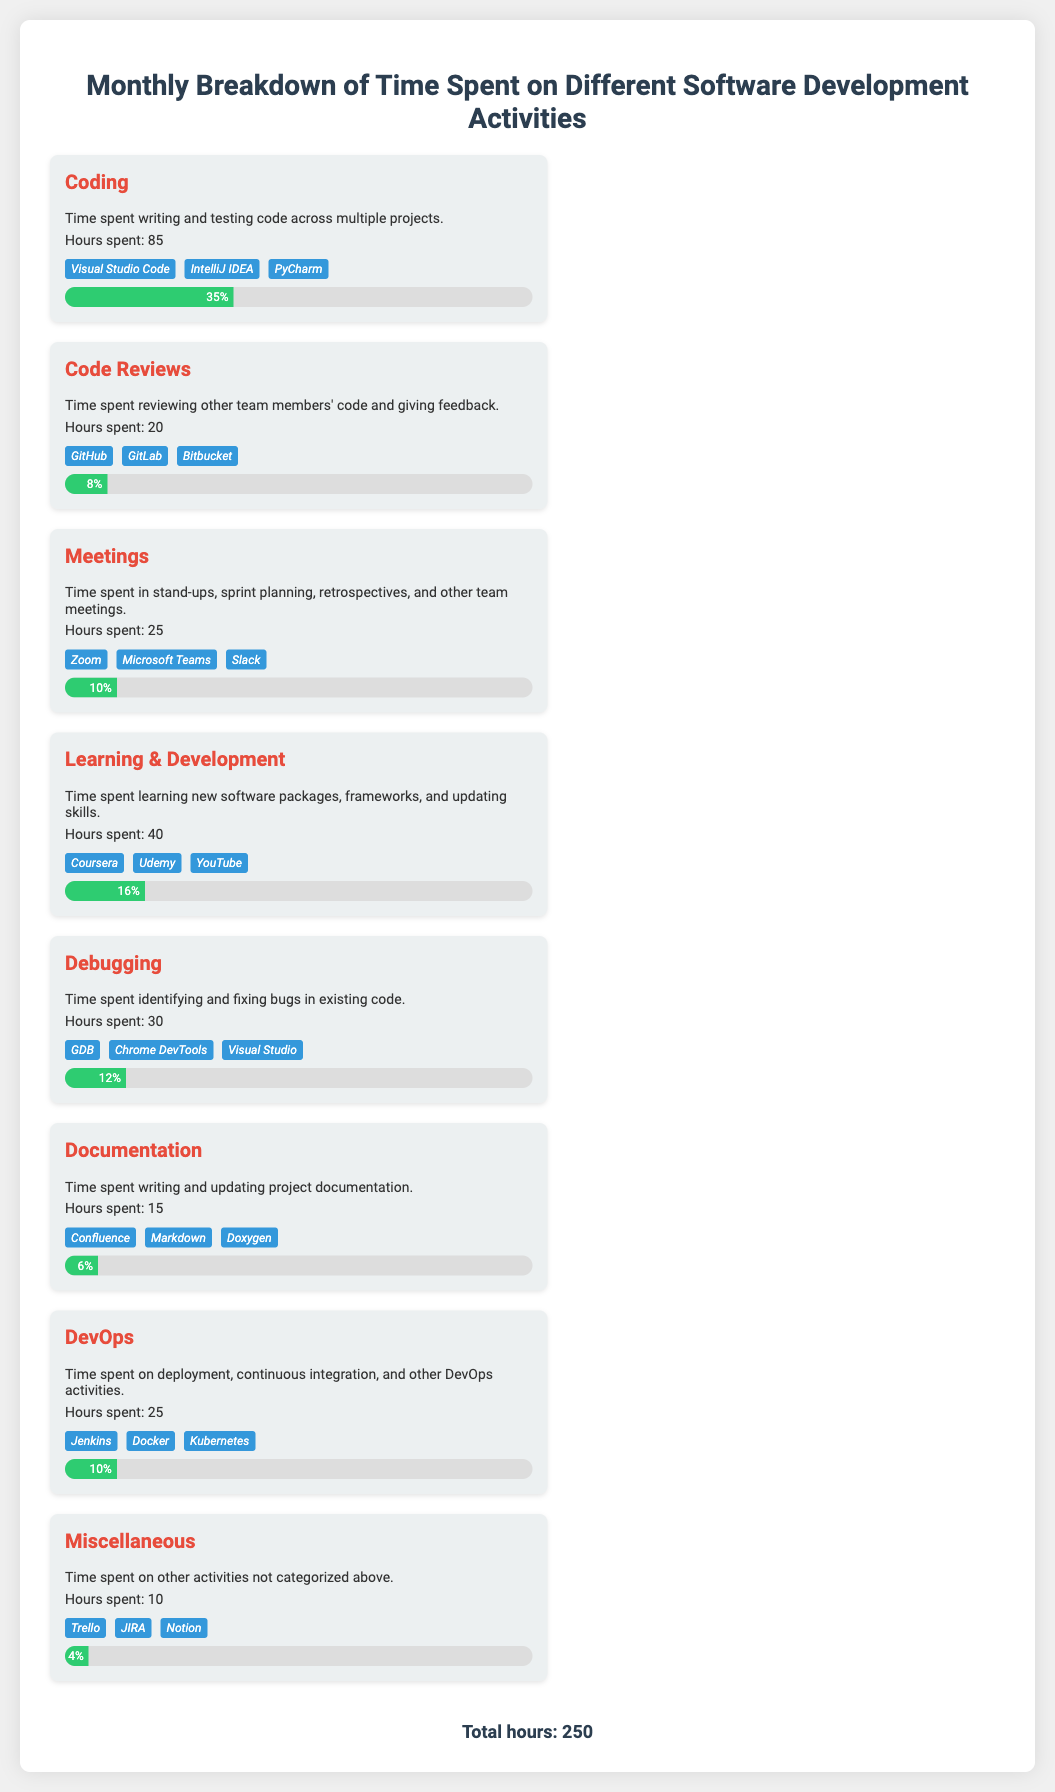What is the total hours spent on software development activities? The total hours spent is the sum of all hours from different activities, which is 250 hours.
Answer: 250 Which activity had the highest hours spent? The activity with the highest hours spent is Coding, which had 85 hours.
Answer: Coding What percentage of time was spent on Learning & Development? The percentage of time spent on Learning & Development is represented by the progress bar which indicates 16%.
Answer: 16% How many hours were dedicated to Code Reviews? The number of hours dedicated to Code Reviews is stated as 20 hours.
Answer: 20 Which tools were used for Debugging? The tools used for Debugging include GDB, Chrome DevTools, and Visual Studio, as listed in the document.
Answer: GDB, Chrome DevTools, Visual Studio What is the percentage of time spent on Documentation? The percentage of time spent on Documentation is shown to be 6%.
Answer: 6% Which activity took up the least time? The activity that took up the least time is Miscellaneous, with 10 hours spent.
Answer: Miscellaneous What are the tools listed under Meetings? The tools listed under Meetings include Zoom, Microsoft Teams, and Slack according to the document.
Answer: Zoom, Microsoft Teams, Slack How many hours were spent on Debugging? The document states that 30 hours were spent on Debugging.
Answer: 30 